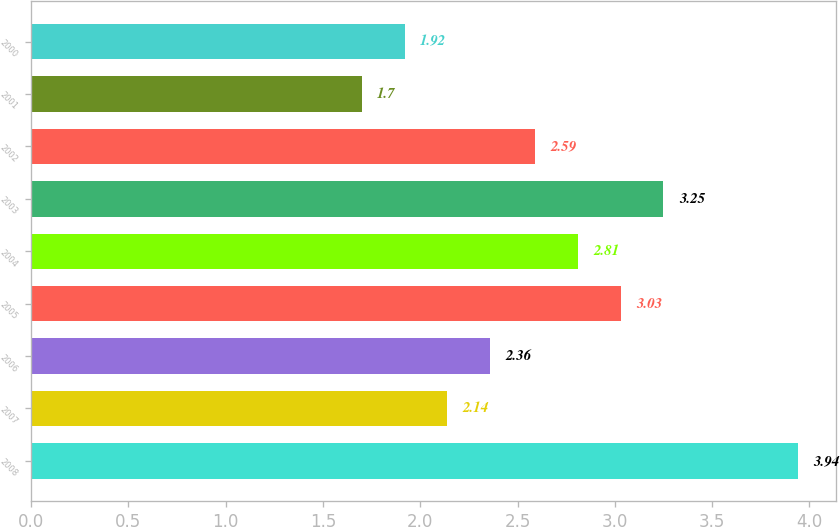Convert chart to OTSL. <chart><loc_0><loc_0><loc_500><loc_500><bar_chart><fcel>2008<fcel>2007<fcel>2006<fcel>2005<fcel>2004<fcel>2003<fcel>2002<fcel>2001<fcel>2000<nl><fcel>3.94<fcel>2.14<fcel>2.36<fcel>3.03<fcel>2.81<fcel>3.25<fcel>2.59<fcel>1.7<fcel>1.92<nl></chart> 